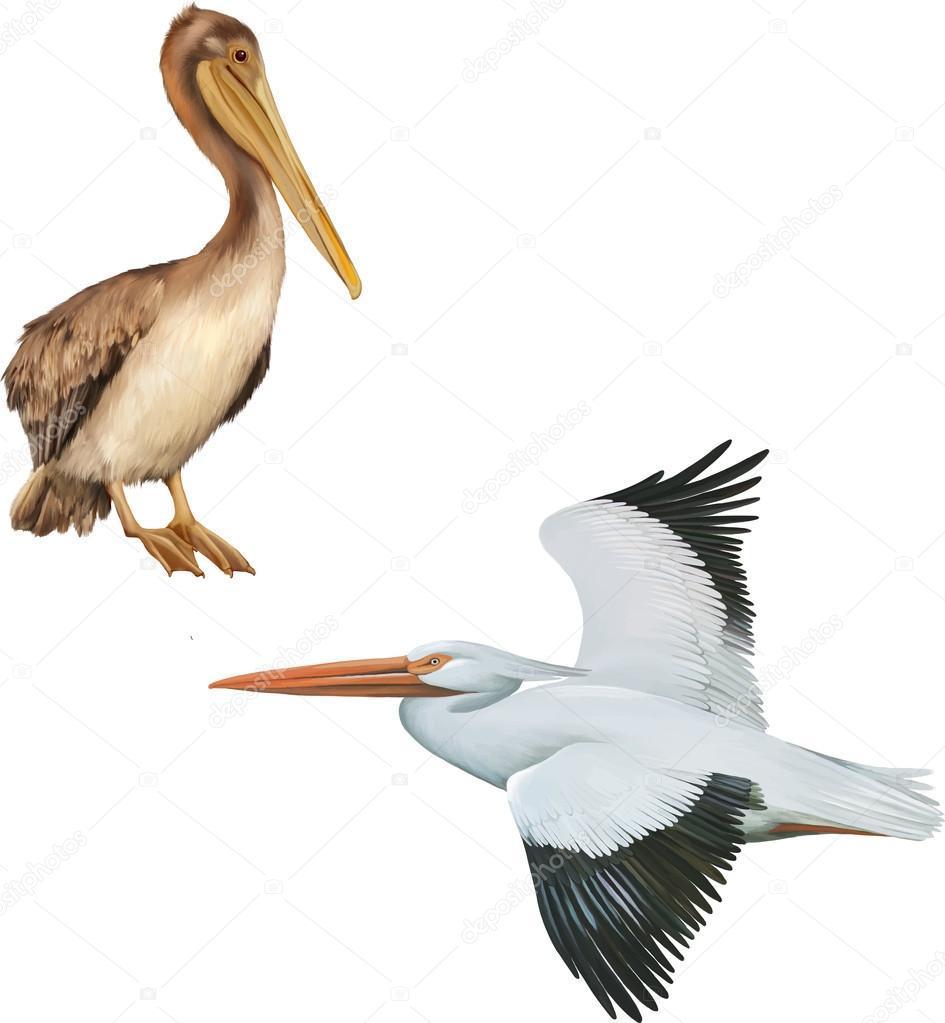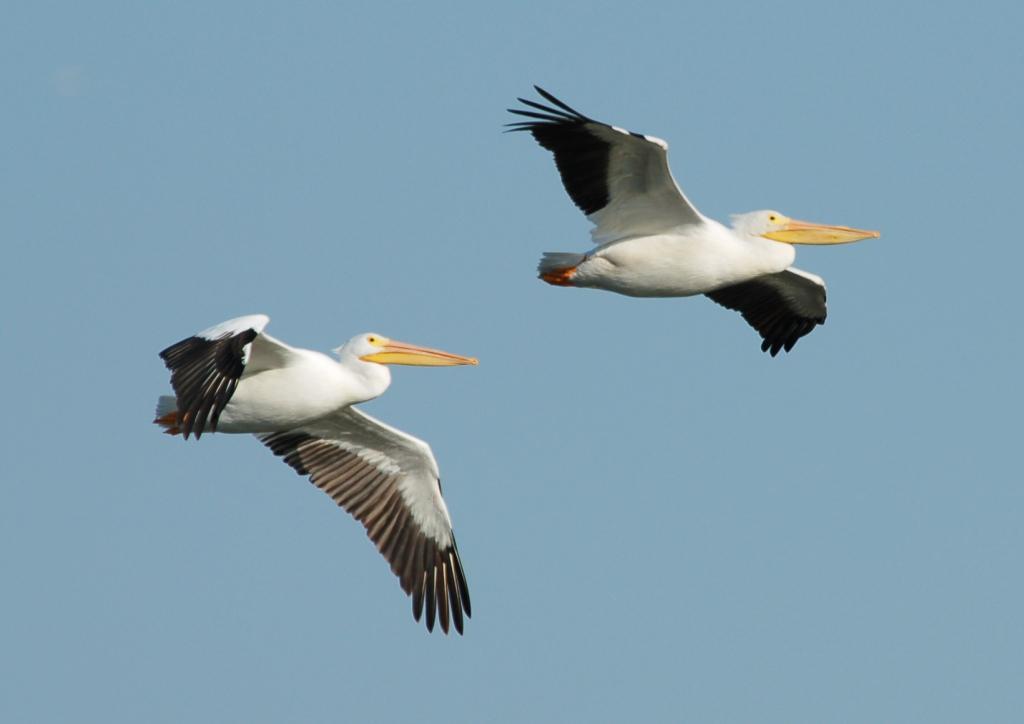The first image is the image on the left, the second image is the image on the right. Examine the images to the left and right. Is the description "AT least 2 black and white pelicans are flying to the right." accurate? Answer yes or no. Yes. The first image is the image on the left, the second image is the image on the right. Assess this claim about the two images: "There are no more than 4 pelicans.". Correct or not? Answer yes or no. Yes. 